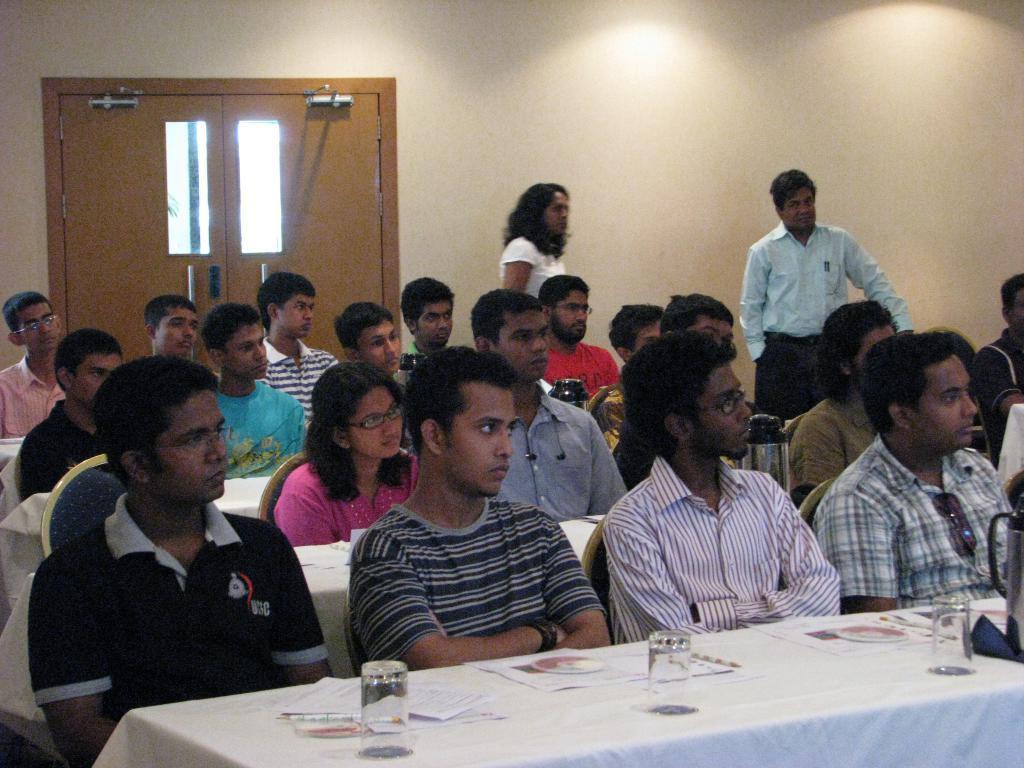How would you summarize this image in a sentence or two? This picture is clicked inside. In the foreground we can see the group of persons sitting on the chairs and we can see the tables on the top of which glasses, papers and some other items are placed. In the background there is a wooden doors and a wall and the two persons standing on the ground. 